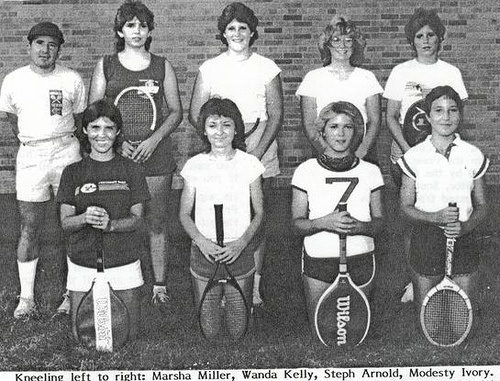Describe the objects in this image and their specific colors. I can see people in darkgray, white, gray, and black tones, people in darkgray, gray, white, and black tones, people in darkgray, gray, black, and white tones, people in darkgray, white, gray, and black tones, and people in darkgray, white, gray, and black tones in this image. 